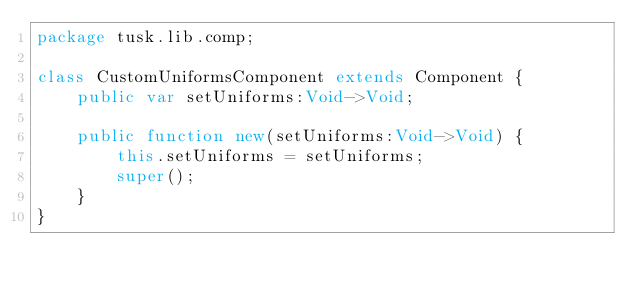<code> <loc_0><loc_0><loc_500><loc_500><_Haxe_>package tusk.lib.comp;

class CustomUniformsComponent extends Component {
	public var setUniforms:Void->Void;

	public function new(setUniforms:Void->Void) {
		this.setUniforms = setUniforms;
		super();
	}
}</code> 